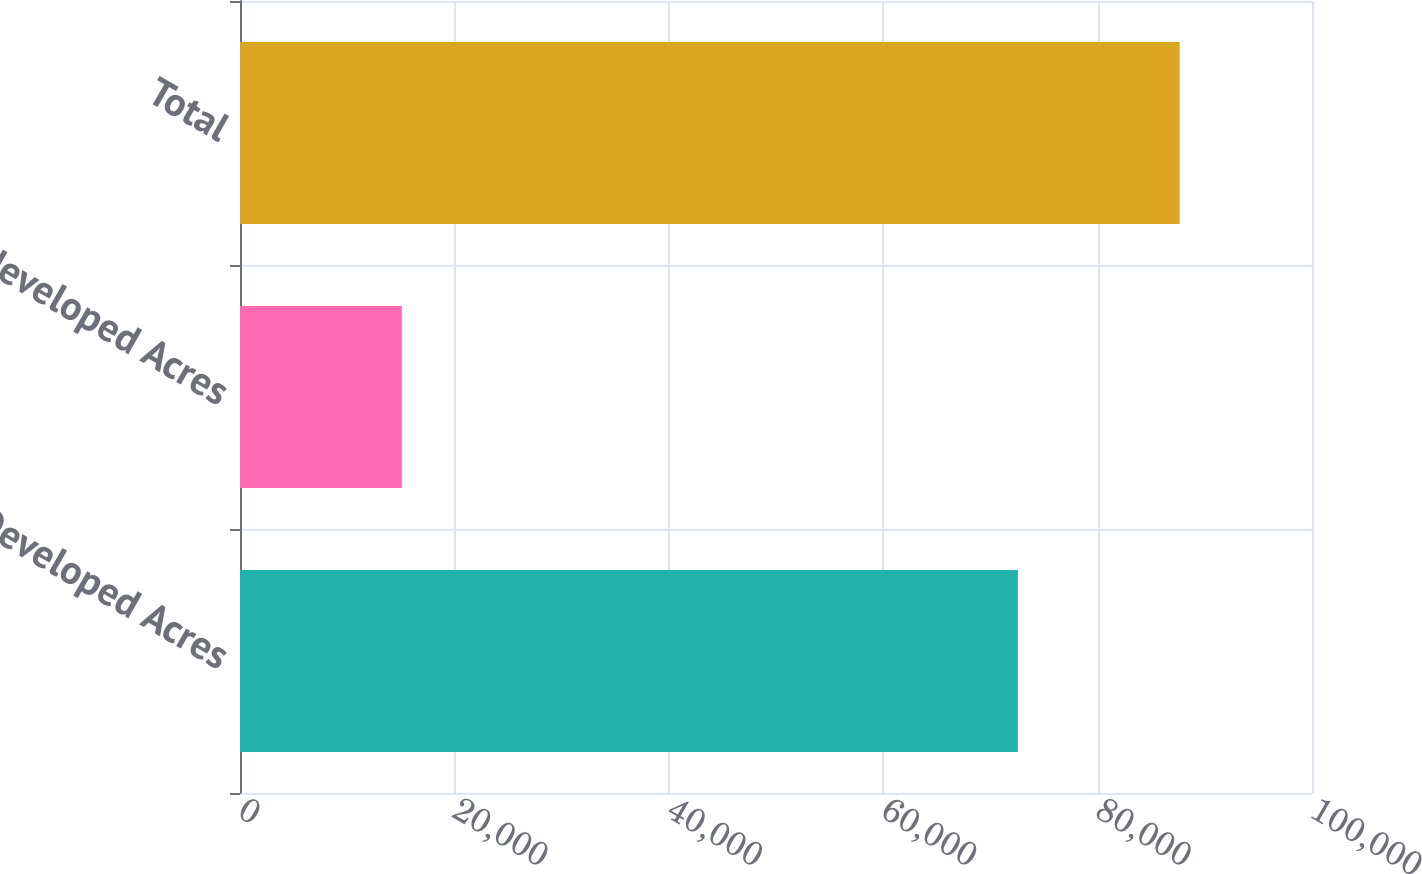<chart> <loc_0><loc_0><loc_500><loc_500><bar_chart><fcel>Developed Acres<fcel>Undeveloped Acres<fcel>Total<nl><fcel>72561<fcel>15093<fcel>87654<nl></chart> 